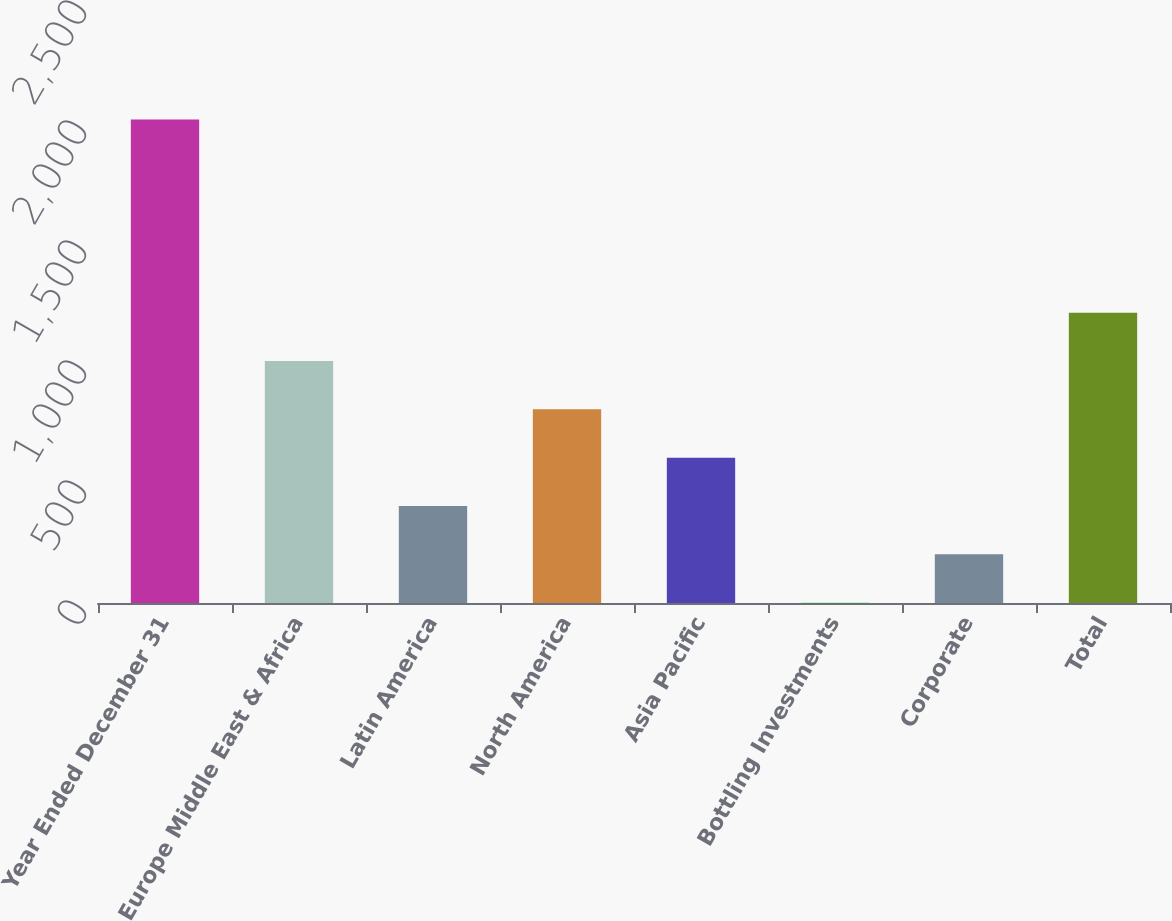<chart> <loc_0><loc_0><loc_500><loc_500><bar_chart><fcel>Year Ended December 31<fcel>Europe Middle East & Africa<fcel>Latin America<fcel>North America<fcel>Asia Pacific<fcel>Bottling Investments<fcel>Corporate<fcel>Total<nl><fcel>2015<fcel>1008.2<fcel>404.12<fcel>806.84<fcel>605.48<fcel>1.4<fcel>202.76<fcel>1209.56<nl></chart> 